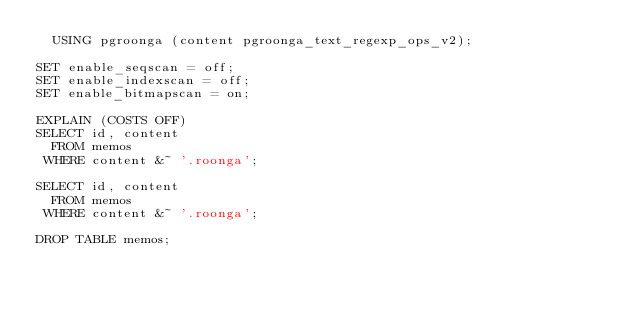<code> <loc_0><loc_0><loc_500><loc_500><_SQL_>  USING pgroonga (content pgroonga_text_regexp_ops_v2);

SET enable_seqscan = off;
SET enable_indexscan = off;
SET enable_bitmapscan = on;

EXPLAIN (COSTS OFF)
SELECT id, content
  FROM memos
 WHERE content &~ '.roonga';

SELECT id, content
  FROM memos
 WHERE content &~ '.roonga';

DROP TABLE memos;
</code> 